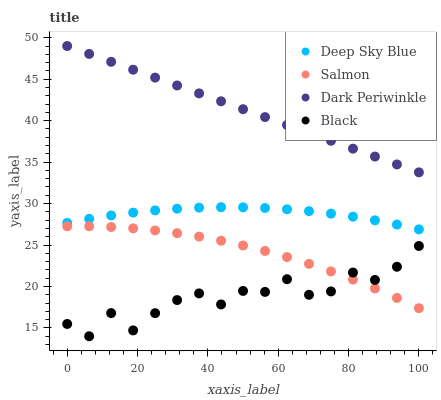Does Black have the minimum area under the curve?
Answer yes or no. Yes. Does Dark Periwinkle have the maximum area under the curve?
Answer yes or no. Yes. Does Salmon have the minimum area under the curve?
Answer yes or no. No. Does Salmon have the maximum area under the curve?
Answer yes or no. No. Is Dark Periwinkle the smoothest?
Answer yes or no. Yes. Is Black the roughest?
Answer yes or no. Yes. Is Salmon the smoothest?
Answer yes or no. No. Is Salmon the roughest?
Answer yes or no. No. Does Black have the lowest value?
Answer yes or no. Yes. Does Salmon have the lowest value?
Answer yes or no. No. Does Dark Periwinkle have the highest value?
Answer yes or no. Yes. Does Salmon have the highest value?
Answer yes or no. No. Is Salmon less than Dark Periwinkle?
Answer yes or no. Yes. Is Dark Periwinkle greater than Deep Sky Blue?
Answer yes or no. Yes. Does Black intersect Salmon?
Answer yes or no. Yes. Is Black less than Salmon?
Answer yes or no. No. Is Black greater than Salmon?
Answer yes or no. No. Does Salmon intersect Dark Periwinkle?
Answer yes or no. No. 